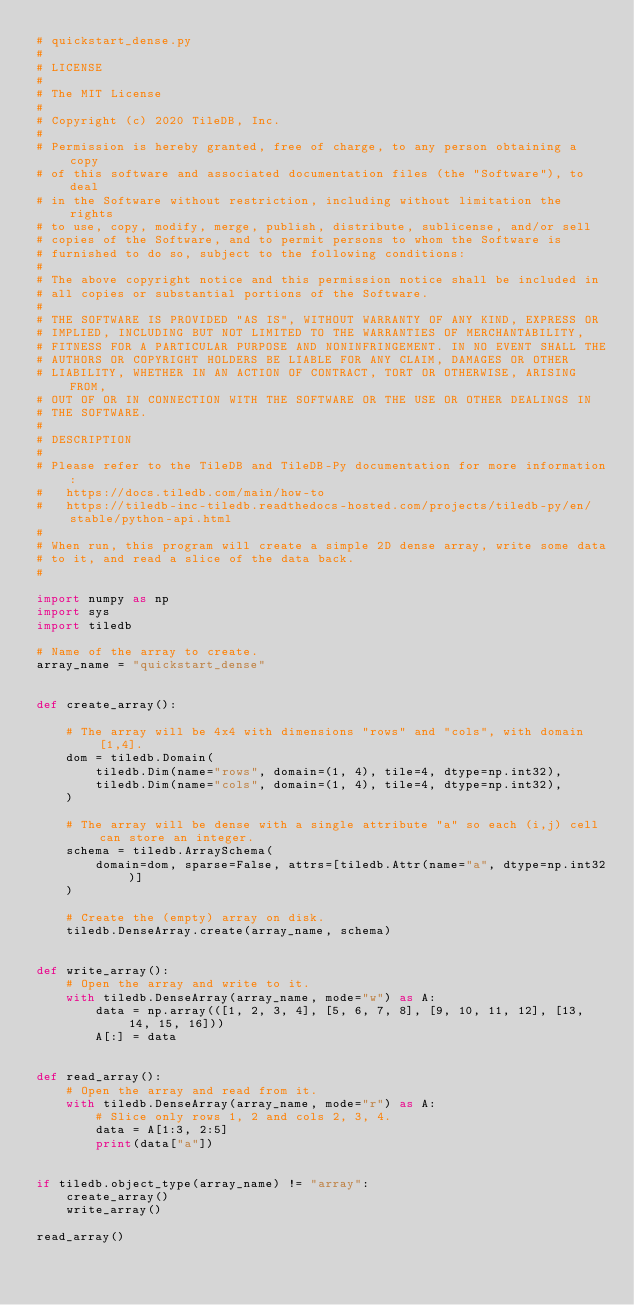<code> <loc_0><loc_0><loc_500><loc_500><_Python_># quickstart_dense.py
#
# LICENSE
#
# The MIT License
#
# Copyright (c) 2020 TileDB, Inc.
#
# Permission is hereby granted, free of charge, to any person obtaining a copy
# of this software and associated documentation files (the "Software"), to deal
# in the Software without restriction, including without limitation the rights
# to use, copy, modify, merge, publish, distribute, sublicense, and/or sell
# copies of the Software, and to permit persons to whom the Software is
# furnished to do so, subject to the following conditions:
#
# The above copyright notice and this permission notice shall be included in
# all copies or substantial portions of the Software.
#
# THE SOFTWARE IS PROVIDED "AS IS", WITHOUT WARRANTY OF ANY KIND, EXPRESS OR
# IMPLIED, INCLUDING BUT NOT LIMITED TO THE WARRANTIES OF MERCHANTABILITY,
# FITNESS FOR A PARTICULAR PURPOSE AND NONINFRINGEMENT. IN NO EVENT SHALL THE
# AUTHORS OR COPYRIGHT HOLDERS BE LIABLE FOR ANY CLAIM, DAMAGES OR OTHER
# LIABILITY, WHETHER IN AN ACTION OF CONTRACT, TORT OR OTHERWISE, ARISING FROM,
# OUT OF OR IN CONNECTION WITH THE SOFTWARE OR THE USE OR OTHER DEALINGS IN
# THE SOFTWARE.
#
# DESCRIPTION
#
# Please refer to the TileDB and TileDB-Py documentation for more information:
#   https://docs.tiledb.com/main/how-to
#   https://tiledb-inc-tiledb.readthedocs-hosted.com/projects/tiledb-py/en/stable/python-api.html
#
# When run, this program will create a simple 2D dense array, write some data
# to it, and read a slice of the data back.
#

import numpy as np
import sys
import tiledb

# Name of the array to create.
array_name = "quickstart_dense"


def create_array():

    # The array will be 4x4 with dimensions "rows" and "cols", with domain [1,4].
    dom = tiledb.Domain(
        tiledb.Dim(name="rows", domain=(1, 4), tile=4, dtype=np.int32),
        tiledb.Dim(name="cols", domain=(1, 4), tile=4, dtype=np.int32),
    )

    # The array will be dense with a single attribute "a" so each (i,j) cell can store an integer.
    schema = tiledb.ArraySchema(
        domain=dom, sparse=False, attrs=[tiledb.Attr(name="a", dtype=np.int32)]
    )

    # Create the (empty) array on disk.
    tiledb.DenseArray.create(array_name, schema)


def write_array():
    # Open the array and write to it.
    with tiledb.DenseArray(array_name, mode="w") as A:
        data = np.array(([1, 2, 3, 4], [5, 6, 7, 8], [9, 10, 11, 12], [13, 14, 15, 16]))
        A[:] = data


def read_array():
    # Open the array and read from it.
    with tiledb.DenseArray(array_name, mode="r") as A:
        # Slice only rows 1, 2 and cols 2, 3, 4.
        data = A[1:3, 2:5]
        print(data["a"])


if tiledb.object_type(array_name) != "array":
    create_array()
    write_array()

read_array()
</code> 